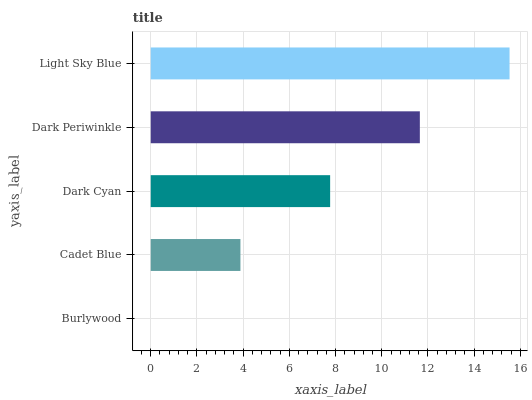Is Burlywood the minimum?
Answer yes or no. Yes. Is Light Sky Blue the maximum?
Answer yes or no. Yes. Is Cadet Blue the minimum?
Answer yes or no. No. Is Cadet Blue the maximum?
Answer yes or no. No. Is Cadet Blue greater than Burlywood?
Answer yes or no. Yes. Is Burlywood less than Cadet Blue?
Answer yes or no. Yes. Is Burlywood greater than Cadet Blue?
Answer yes or no. No. Is Cadet Blue less than Burlywood?
Answer yes or no. No. Is Dark Cyan the high median?
Answer yes or no. Yes. Is Dark Cyan the low median?
Answer yes or no. Yes. Is Light Sky Blue the high median?
Answer yes or no. No. Is Cadet Blue the low median?
Answer yes or no. No. 